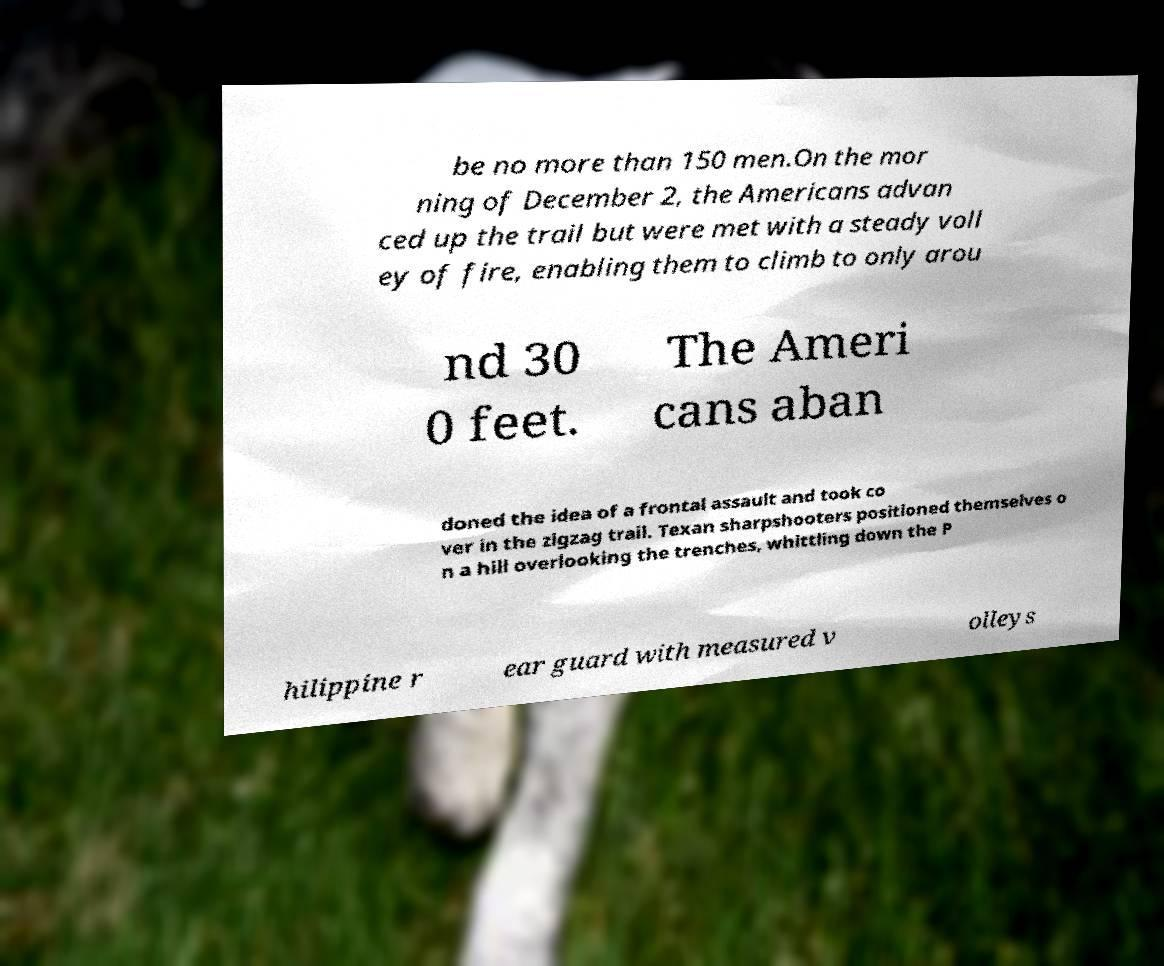There's text embedded in this image that I need extracted. Can you transcribe it verbatim? be no more than 150 men.On the mor ning of December 2, the Americans advan ced up the trail but were met with a steady voll ey of fire, enabling them to climb to only arou nd 30 0 feet. The Ameri cans aban doned the idea of a frontal assault and took co ver in the zigzag trail. Texan sharpshooters positioned themselves o n a hill overlooking the trenches, whittling down the P hilippine r ear guard with measured v olleys 